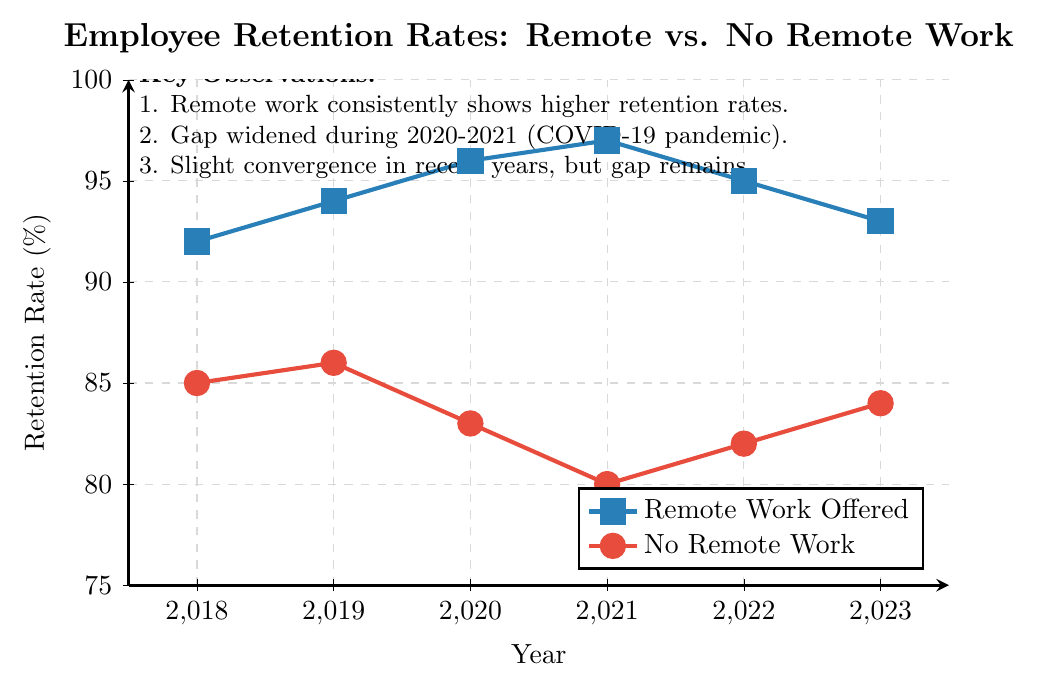What's the highest retention rate for employees offered remote work? By looking at the highest point on the blue line, which represents employees offered remote work, we see the highest value is in 2021. The y-axis shows this value as 97%.
Answer: 97% Which year showed the largest gap in retention rates between remote work offered and no remote work? To find the largest gap, we check the difference between the two lines for each year. In 2021, the gap is most pronounced: Remote = 97%, No Remote = 80%. The difference is 97% - 80% = 17%.
Answer: 2021 How did the retention rates for employees with no remote work change from 2018 to 2019? Observing the red line, in 2018 the retention rate was 85% and in 2019 it was 86%. The change is 86% - 85% = 1%.
Answer: Increased by 1% Comparing 2020 and 2021, which group showed a more significant variation in retention rates? Checking the change for both lines between 2020 and 2021: Remote changed from 96% to 97% (increase of 1%), and No Remote changed from 83% to 80% (decrease of 3%). The No Remote group had a more significant variation.
Answer: No Remote Over the years, which trend is consistently observed in terms of employee retention between remote work and no remote work options? The blue line (Remote Work Offered) is consistently above the red line (No Remote Work) each year, indicating higher retention rates for employees offered remote work every year.
Answer: Remote Work Offered always higher In which year did employees offered remote work show a decrease in retention compared to the previous year? Inspecting the blue line, the retention rate decreases from 97% in 2021 to 95% in 2022 and further to 93% in 2023.
Answer: 2022 and 2023 What is the average retention rate of employees with no remote work over the six years? Adding the retention rates for No Remote Work from 2018 to 2023: 85% + 86% + 83% + 80% + 82% + 84% = 500%. Dividing by 6, we get 500% / 6 ≈ 83.33%.
Answer: 83.33% How did the retention rate for employees offered remote work change during the pandemic years (2020-2021)? During the pandemic years, the blue line goes from 96% in 2020 to 97% in 2021. The retention rate increased by 1%.
Answer: Increased by 1% What can be inferred from the trend between 2021 and 2023 for employees offered remote work? From 2021 to 2023, the blue line shows a decline in retention rates from 97% to 95% to 93%, indicating a slight decrease over these years.
Answer: Decline in retention rates Is there a year when the retention rate of employees without remote work exceeds those with remote work? Observing both lines throughout the years 2018 to 2023, there is no point where the red line (No Remote Work) is above the blue line (Remote Work Offered).
Answer: No 